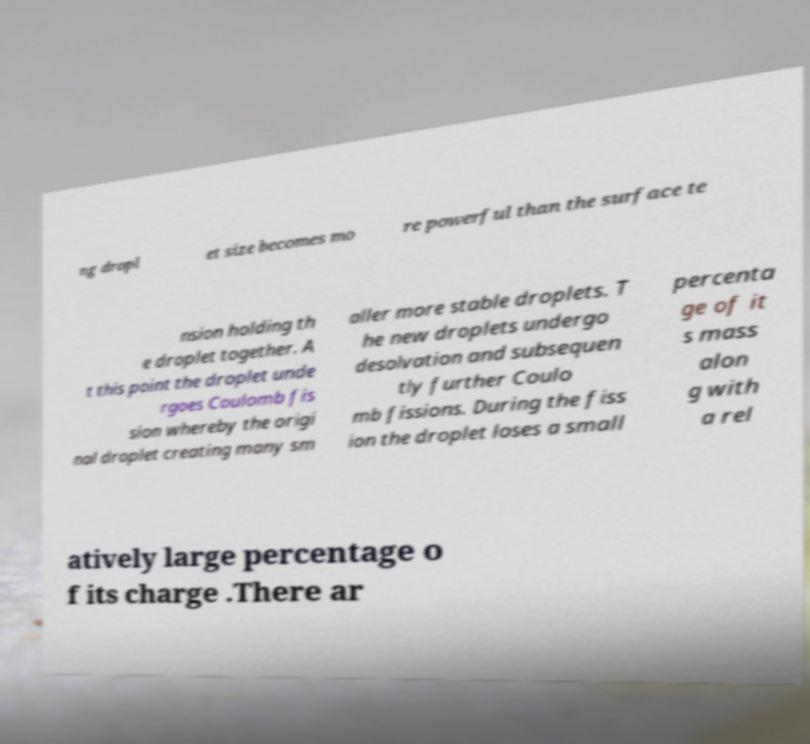Please identify and transcribe the text found in this image. ng dropl et size becomes mo re powerful than the surface te nsion holding th e droplet together. A t this point the droplet unde rgoes Coulomb fis sion whereby the origi nal droplet creating many sm aller more stable droplets. T he new droplets undergo desolvation and subsequen tly further Coulo mb fissions. During the fiss ion the droplet loses a small percenta ge of it s mass alon g with a rel atively large percentage o f its charge .There ar 